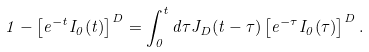Convert formula to latex. <formula><loc_0><loc_0><loc_500><loc_500>1 - \left [ e ^ { - t } I _ { 0 } ( t ) \right ] ^ { D } = \int _ { 0 } ^ { t } d \tau J _ { D } ( t - \tau ) \left [ e ^ { - \tau } I _ { 0 } ( \tau ) \right ] ^ { D } .</formula> 